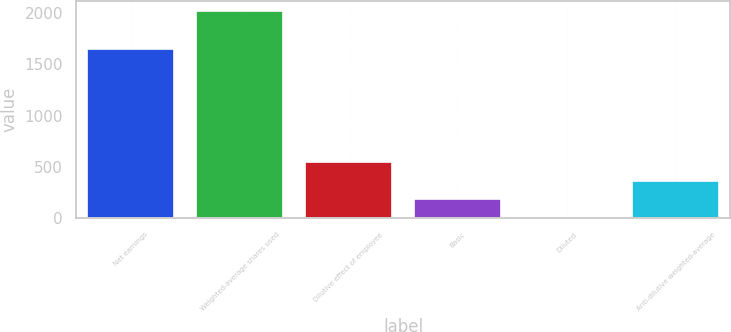<chart> <loc_0><loc_0><loc_500><loc_500><bar_chart><fcel>Net earnings<fcel>Weighted-average shares used<fcel>Dilutive effect of employee<fcel>Basic<fcel>Diluted<fcel>Anti-dilutive weighted-average<nl><fcel>1648<fcel>2014.62<fcel>550.83<fcel>184.21<fcel>0.9<fcel>367.52<nl></chart> 